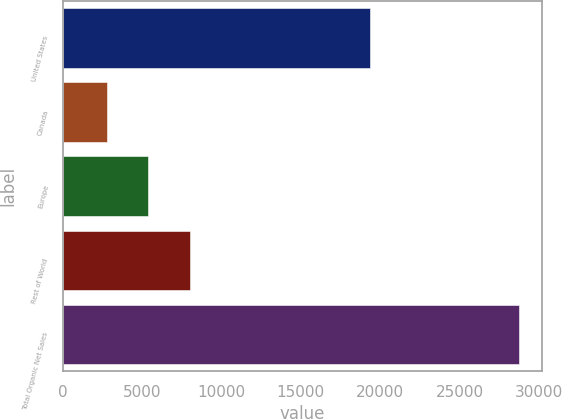Convert chart. <chart><loc_0><loc_0><loc_500><loc_500><bar_chart><fcel>United States<fcel>Canada<fcel>Europe<fcel>Rest of World<fcel>Total Organic Net Sales<nl><fcel>19346<fcel>2811<fcel>5404<fcel>7997<fcel>28741<nl></chart> 